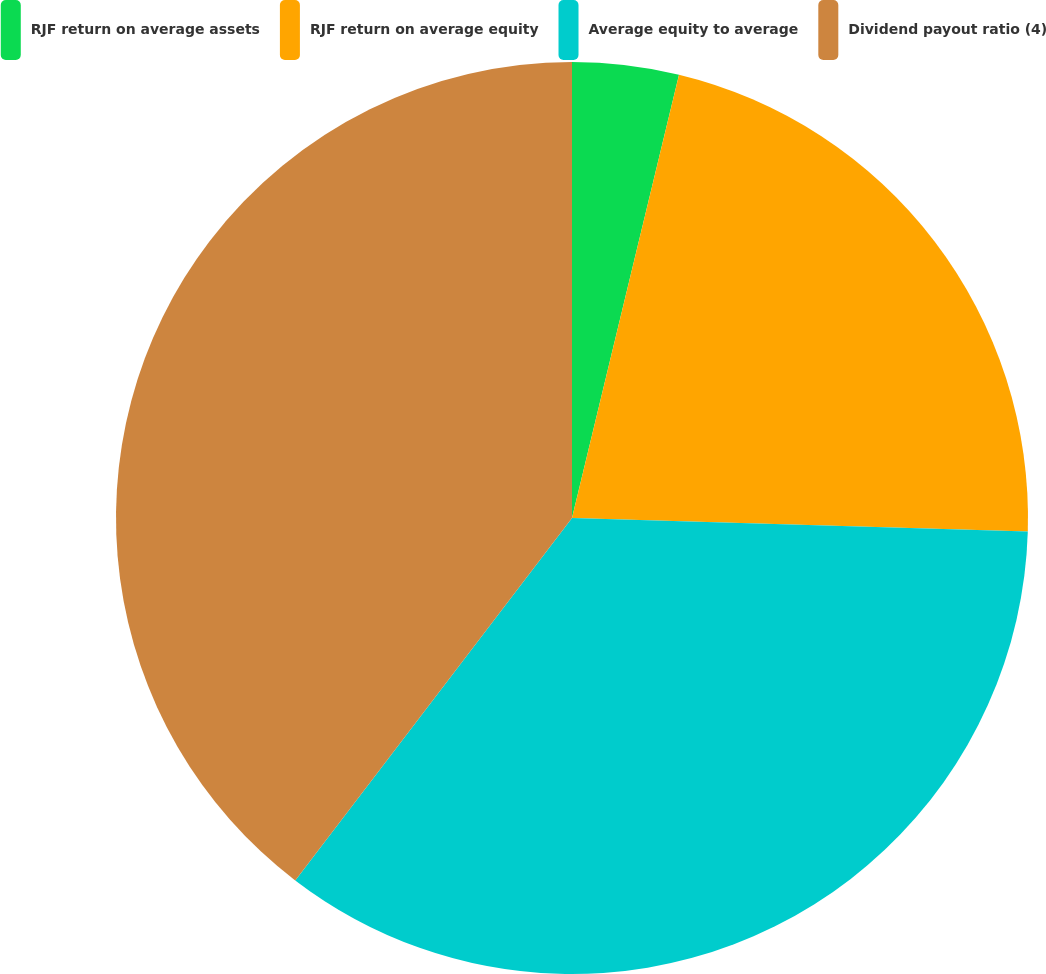Convert chart. <chart><loc_0><loc_0><loc_500><loc_500><pie_chart><fcel>RJF return on average assets<fcel>RJF return on average equity<fcel>Average equity to average<fcel>Dividend payout ratio (4)<nl><fcel>3.77%<fcel>21.7%<fcel>34.91%<fcel>39.62%<nl></chart> 